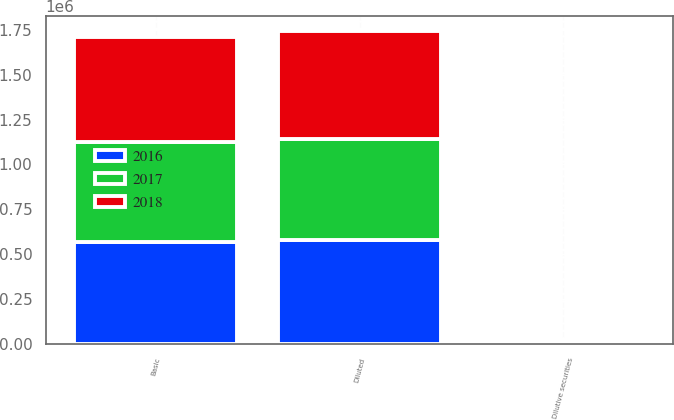<chart> <loc_0><loc_0><loc_500><loc_500><stacked_bar_chart><ecel><fcel>Basic<fcel>Dilutive securities<fcel>Diluted<nl><fcel>2017<fcel>557166<fcel>7088<fcel>564254<nl><fcel>2016<fcel>566782<fcel>10359<fcel>577141<nl><fcel>2018<fcel>587874<fcel>11945<fcel>599819<nl></chart> 